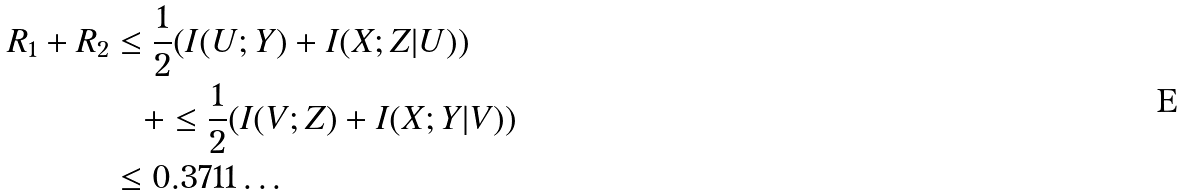<formula> <loc_0><loc_0><loc_500><loc_500>R _ { 1 } + R _ { 2 } & \leq \frac { 1 } { 2 } ( I ( U ; Y ) + I ( X ; Z | U ) ) \\ & \quad + \leq \frac { 1 } { 2 } ( I ( V ; Z ) + I ( X ; Y | V ) ) \\ & \leq 0 . 3 7 1 1 \dots</formula> 